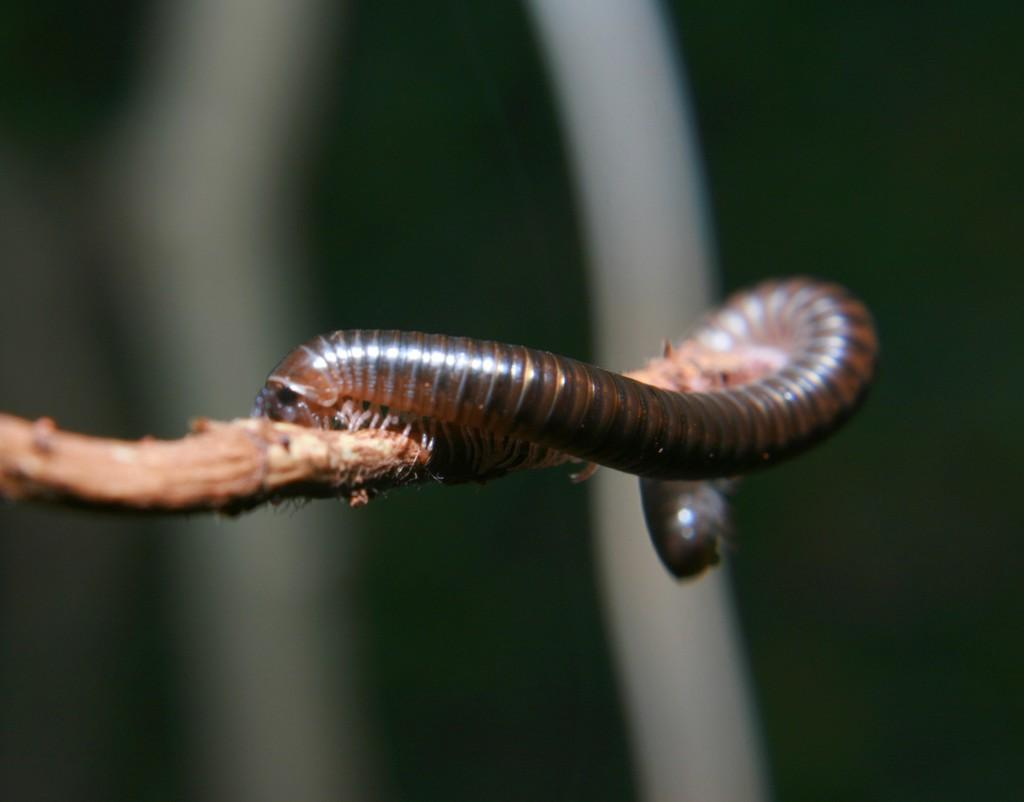What is the main subject of the image? The main subject of the image is a worm. Where is the worm located in the image? The worm is on a stem in the image. What is the tendency of the worm to stick to the blade in the image? There is no blade present in the image, so the worm's tendency to stick to a blade cannot be determined. 